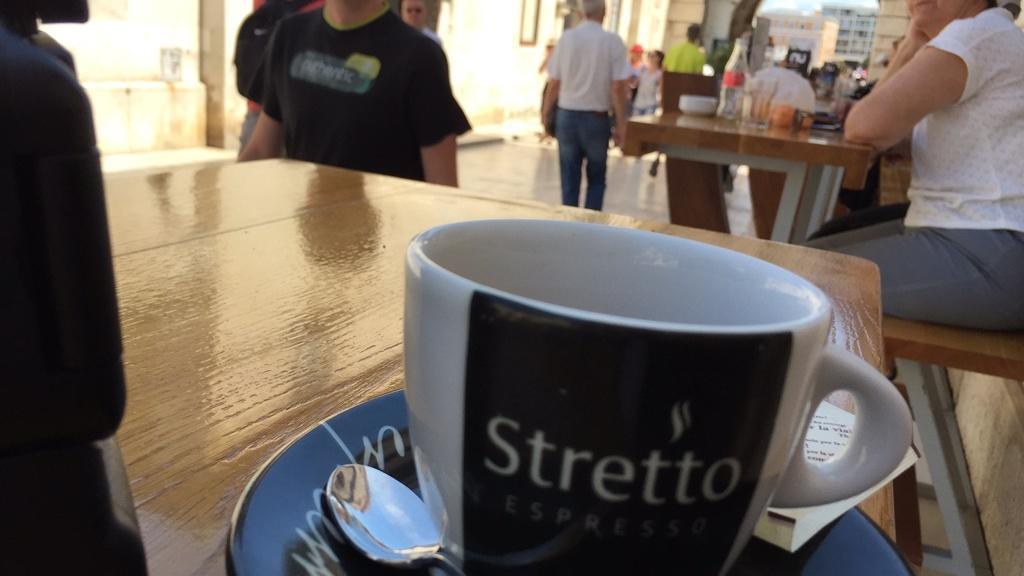In one or two sentences, can you explain what this image depicts? In this image I can see few people where few of them are sitting and rest all are standing. I can also see few table and on these tables I can see cup, plate, a spoon and a bottle. 